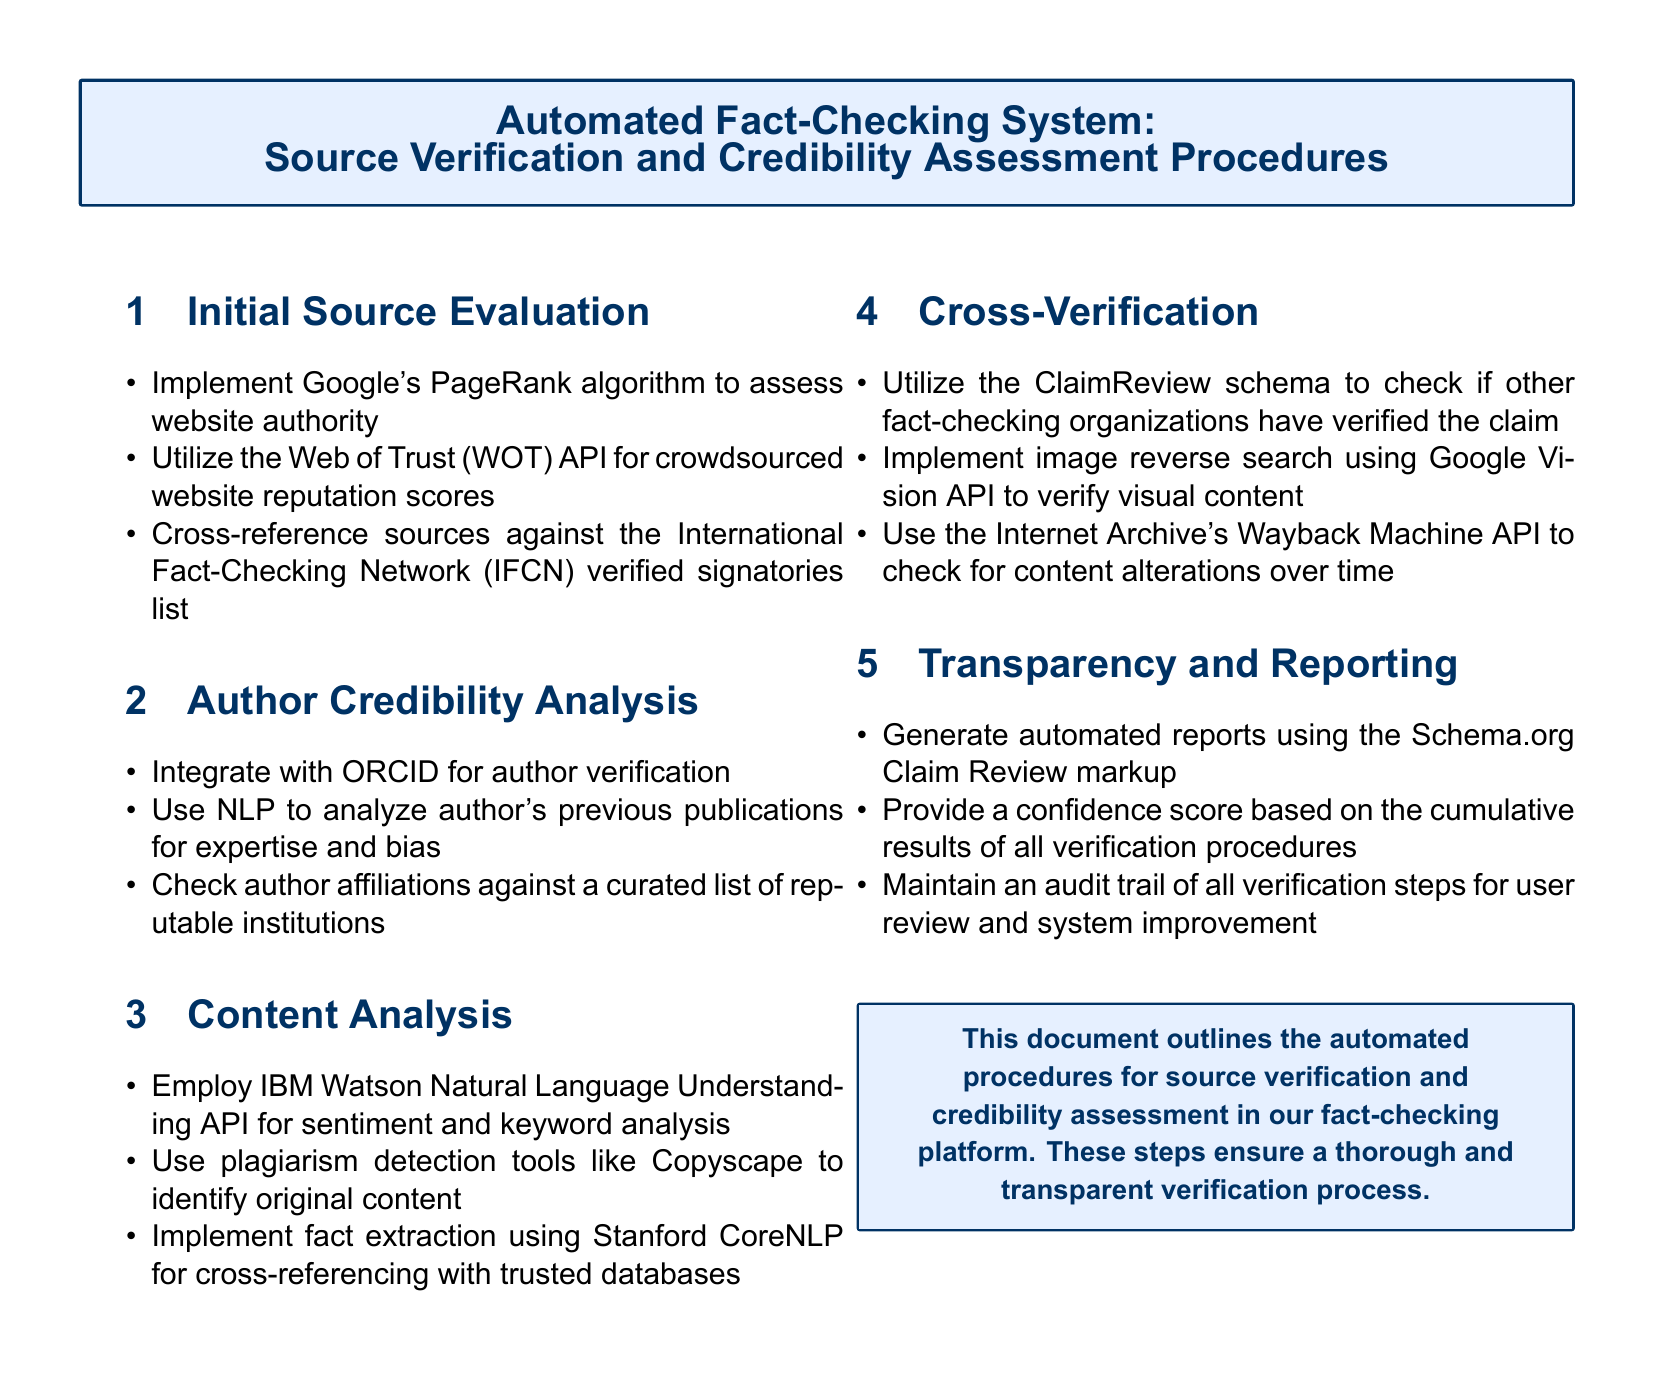What algorithm is implemented for assessing website authority? The document states that Google's PageRank algorithm is used to assess website authority.
Answer: Google's PageRank algorithm Which API is used for crowdsourced website reputation scores? The Web of Trust (WOT) API is utilized as mentioned in the document for crowdsourced website reputation scores.
Answer: Web of Trust (WOT) API What tool is mentioned for analyzing sentiment and keywords? The IBM Watson Natural Language Understanding API is employed for sentiment and keyword analysis according to the content analysis section.
Answer: IBM Watson Natural Language Understanding API What is the purpose of the ClaimReview schema? The ClaimReview schema is utilized to check if other fact-checking organizations have verified the claim, as indicated under the cross-verification section.
Answer: Check verification status How is author credibility assessed? Author credibility is assessed through integration with ORCID for author verification, as stated in the author credibility analysis section.
Answer: ORCID What is generated to provide transparency in the verification process? The document mentions that automated reports are generated using the Schema.org Claim Review markup for transparency.
Answer: Automated reports What do the verification procedures contribute towards? They contribute towards providing a confidence score based on the cumulative results of all verification procedures, as noted in the transparency and reporting section.
Answer: Confidence score How is visual content verified? Visual content is verified using image reverse search via the Google Vision API, as described in the cross-verification section.
Answer: Google Vision API What type of document is outlined? The document outlines the automated procedures for source verification and credibility assessment in a fact-checking platform.
Answer: Automated procedures 